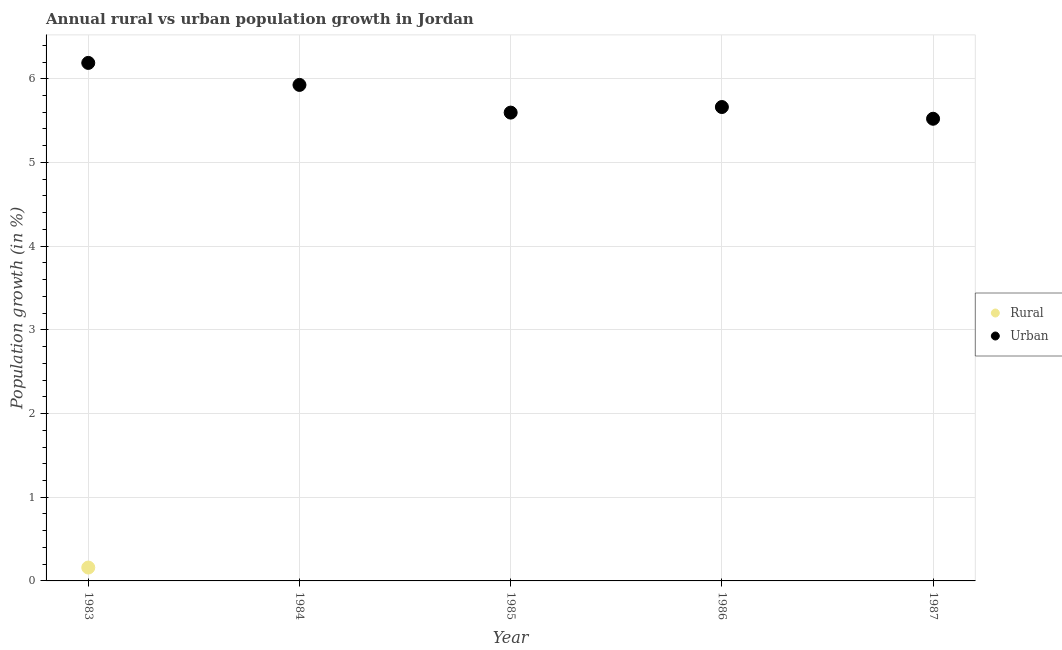What is the rural population growth in 1983?
Your answer should be very brief. 0.16. Across all years, what is the maximum urban population growth?
Provide a succinct answer. 6.19. In which year was the rural population growth maximum?
Offer a terse response. 1983. What is the total urban population growth in the graph?
Keep it short and to the point. 28.89. What is the difference between the urban population growth in 1985 and that in 1986?
Keep it short and to the point. -0.07. What is the difference between the rural population growth in 1983 and the urban population growth in 1986?
Your answer should be very brief. -5.5. What is the average urban population growth per year?
Ensure brevity in your answer.  5.78. In the year 1983, what is the difference between the rural population growth and urban population growth?
Keep it short and to the point. -6.03. In how many years, is the urban population growth greater than 6.2 %?
Give a very brief answer. 0. What is the ratio of the urban population growth in 1985 to that in 1986?
Give a very brief answer. 0.99. What is the difference between the highest and the second highest urban population growth?
Provide a short and direct response. 0.26. What is the difference between the highest and the lowest urban population growth?
Make the answer very short. 0.67. In how many years, is the urban population growth greater than the average urban population growth taken over all years?
Offer a very short reply. 2. Is the sum of the urban population growth in 1984 and 1985 greater than the maximum rural population growth across all years?
Offer a terse response. Yes. Does the rural population growth monotonically increase over the years?
Your answer should be very brief. No. Is the rural population growth strictly greater than the urban population growth over the years?
Your answer should be very brief. No. How many dotlines are there?
Your answer should be compact. 2. How many years are there in the graph?
Keep it short and to the point. 5. What is the difference between two consecutive major ticks on the Y-axis?
Give a very brief answer. 1. Are the values on the major ticks of Y-axis written in scientific E-notation?
Ensure brevity in your answer.  No. Does the graph contain any zero values?
Offer a very short reply. Yes. Where does the legend appear in the graph?
Offer a terse response. Center right. How many legend labels are there?
Provide a succinct answer. 2. What is the title of the graph?
Keep it short and to the point. Annual rural vs urban population growth in Jordan. What is the label or title of the Y-axis?
Provide a short and direct response. Population growth (in %). What is the Population growth (in %) of Rural in 1983?
Give a very brief answer. 0.16. What is the Population growth (in %) of Urban  in 1983?
Offer a very short reply. 6.19. What is the Population growth (in %) of Rural in 1984?
Provide a succinct answer. 0. What is the Population growth (in %) in Urban  in 1984?
Offer a very short reply. 5.93. What is the Population growth (in %) in Urban  in 1985?
Keep it short and to the point. 5.6. What is the Population growth (in %) in Urban  in 1986?
Provide a succinct answer. 5.66. What is the Population growth (in %) of Urban  in 1987?
Your response must be concise. 5.52. Across all years, what is the maximum Population growth (in %) in Rural?
Provide a succinct answer. 0.16. Across all years, what is the maximum Population growth (in %) in Urban ?
Provide a short and direct response. 6.19. Across all years, what is the minimum Population growth (in %) in Rural?
Your response must be concise. 0. Across all years, what is the minimum Population growth (in %) of Urban ?
Provide a short and direct response. 5.52. What is the total Population growth (in %) in Rural in the graph?
Ensure brevity in your answer.  0.16. What is the total Population growth (in %) of Urban  in the graph?
Ensure brevity in your answer.  28.89. What is the difference between the Population growth (in %) of Urban  in 1983 and that in 1984?
Offer a terse response. 0.26. What is the difference between the Population growth (in %) of Urban  in 1983 and that in 1985?
Your answer should be compact. 0.59. What is the difference between the Population growth (in %) in Urban  in 1983 and that in 1986?
Offer a terse response. 0.53. What is the difference between the Population growth (in %) in Urban  in 1983 and that in 1987?
Offer a terse response. 0.67. What is the difference between the Population growth (in %) in Urban  in 1984 and that in 1985?
Offer a very short reply. 0.33. What is the difference between the Population growth (in %) in Urban  in 1984 and that in 1986?
Provide a succinct answer. 0.26. What is the difference between the Population growth (in %) in Urban  in 1984 and that in 1987?
Ensure brevity in your answer.  0.4. What is the difference between the Population growth (in %) of Urban  in 1985 and that in 1986?
Offer a very short reply. -0.07. What is the difference between the Population growth (in %) of Urban  in 1985 and that in 1987?
Provide a succinct answer. 0.07. What is the difference between the Population growth (in %) in Urban  in 1986 and that in 1987?
Offer a very short reply. 0.14. What is the difference between the Population growth (in %) in Rural in 1983 and the Population growth (in %) in Urban  in 1984?
Make the answer very short. -5.77. What is the difference between the Population growth (in %) of Rural in 1983 and the Population growth (in %) of Urban  in 1985?
Keep it short and to the point. -5.44. What is the difference between the Population growth (in %) of Rural in 1983 and the Population growth (in %) of Urban  in 1986?
Give a very brief answer. -5.5. What is the difference between the Population growth (in %) of Rural in 1983 and the Population growth (in %) of Urban  in 1987?
Keep it short and to the point. -5.36. What is the average Population growth (in %) in Rural per year?
Make the answer very short. 0.03. What is the average Population growth (in %) of Urban  per year?
Your answer should be compact. 5.78. In the year 1983, what is the difference between the Population growth (in %) in Rural and Population growth (in %) in Urban ?
Your answer should be compact. -6.03. What is the ratio of the Population growth (in %) in Urban  in 1983 to that in 1984?
Your answer should be compact. 1.04. What is the ratio of the Population growth (in %) of Urban  in 1983 to that in 1985?
Make the answer very short. 1.11. What is the ratio of the Population growth (in %) in Urban  in 1983 to that in 1986?
Make the answer very short. 1.09. What is the ratio of the Population growth (in %) in Urban  in 1983 to that in 1987?
Give a very brief answer. 1.12. What is the ratio of the Population growth (in %) in Urban  in 1984 to that in 1985?
Offer a very short reply. 1.06. What is the ratio of the Population growth (in %) of Urban  in 1984 to that in 1986?
Your answer should be very brief. 1.05. What is the ratio of the Population growth (in %) of Urban  in 1984 to that in 1987?
Give a very brief answer. 1.07. What is the ratio of the Population growth (in %) in Urban  in 1985 to that in 1986?
Provide a succinct answer. 0.99. What is the ratio of the Population growth (in %) of Urban  in 1985 to that in 1987?
Your answer should be compact. 1.01. What is the ratio of the Population growth (in %) in Urban  in 1986 to that in 1987?
Offer a terse response. 1.03. What is the difference between the highest and the second highest Population growth (in %) of Urban ?
Make the answer very short. 0.26. What is the difference between the highest and the lowest Population growth (in %) of Rural?
Offer a terse response. 0.16. What is the difference between the highest and the lowest Population growth (in %) in Urban ?
Ensure brevity in your answer.  0.67. 